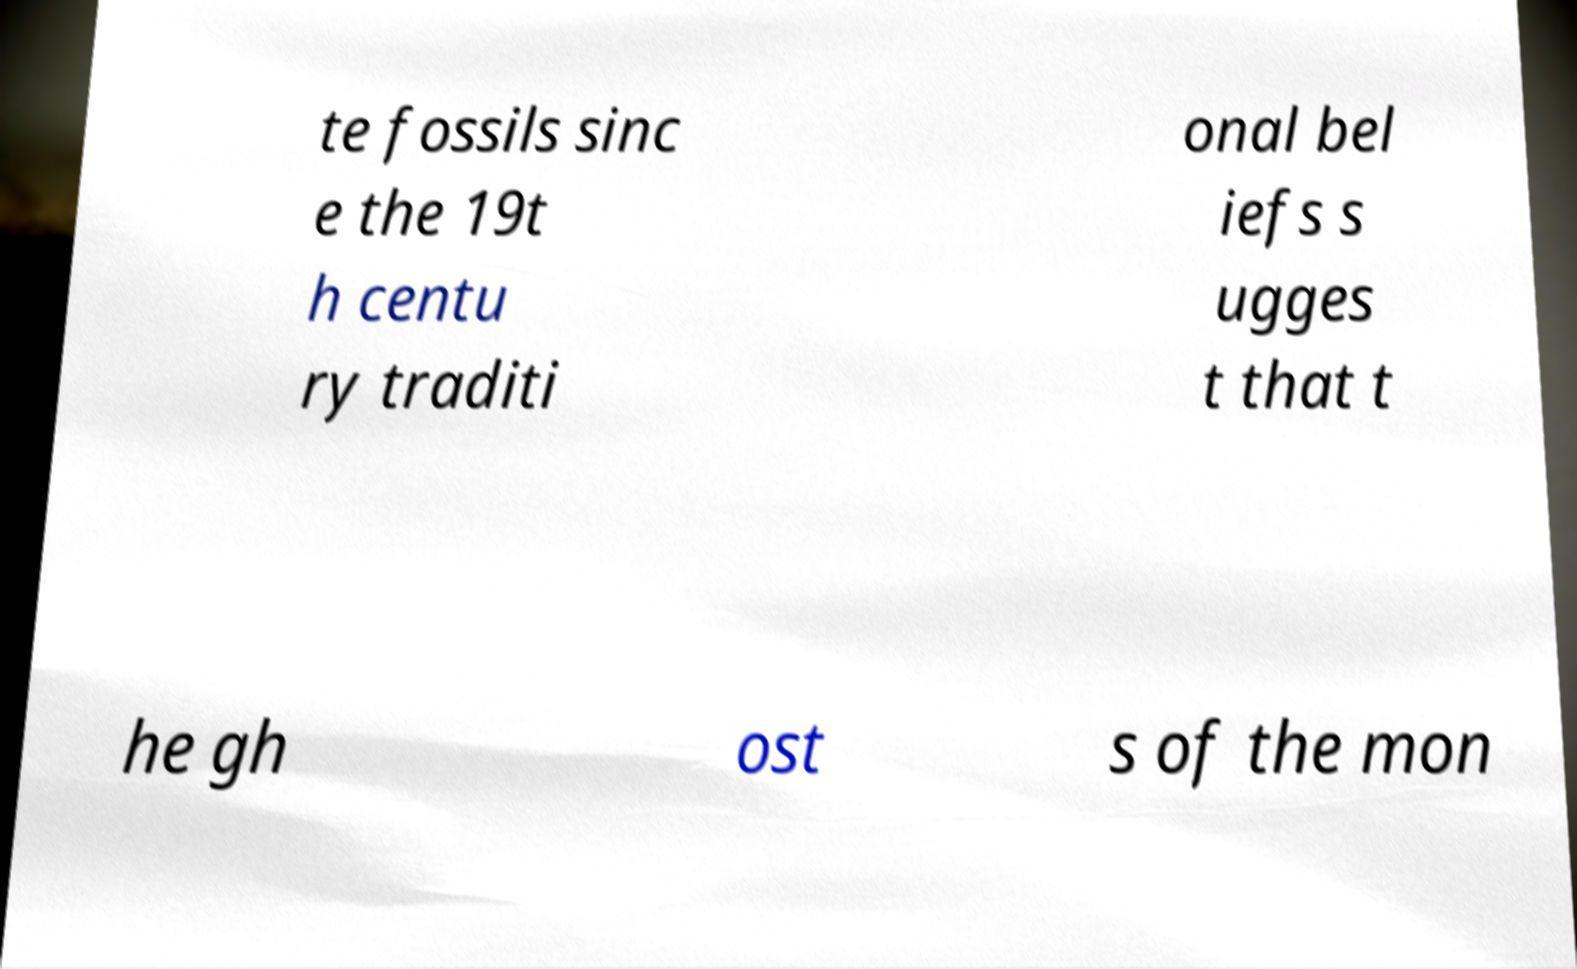I need the written content from this picture converted into text. Can you do that? te fossils sinc e the 19t h centu ry traditi onal bel iefs s ugges t that t he gh ost s of the mon 